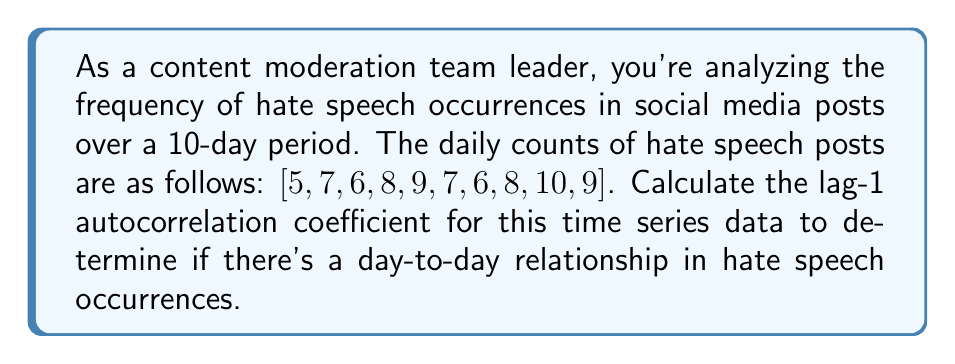Help me with this question. To calculate the lag-1 autocorrelation coefficient, we'll follow these steps:

1. Calculate the mean ($\mu$) of the time series:
   $$\mu = \frac{5 + 7 + 6 + 8 + 9 + 7 + 6 + 8 + 10 + 9}{10} = 7.5$$

2. Calculate the variance ($\sigma^2$) of the time series:
   $$\sigma^2 = \frac{1}{N} \sum_{t=1}^N (x_t - \mu)^2$$
   Where $N$ is the number of observations (10) and $x_t$ are the individual values.
   
   $$\sigma^2 = \frac{1}{10}[(5-7.5)^2 + (7-7.5)^2 + ... + (9-7.5)^2] = 2.45$$

3. Calculate the autocovariance at lag 1:
   $$\gamma_1 = \frac{1}{N-1} \sum_{t=1}^{N-1} (x_t - \mu)(x_{t+1} - \mu)$$
   
   $$\gamma_1 = \frac{1}{9}[(5-7.5)(7-7.5) + (7-7.5)(6-7.5) + ... + (8-7.5)(9-7.5)]$$
   
   $$\gamma_1 = 0.6944$$

4. Calculate the lag-1 autocorrelation coefficient ($\rho_1$):
   $$\rho_1 = \frac{\gamma_1}{\sigma^2} = \frac{0.6944}{2.45} = 0.2834$$

The lag-1 autocorrelation coefficient is approximately 0.2834.
Answer: $\rho_1 \approx 0.2834$ 